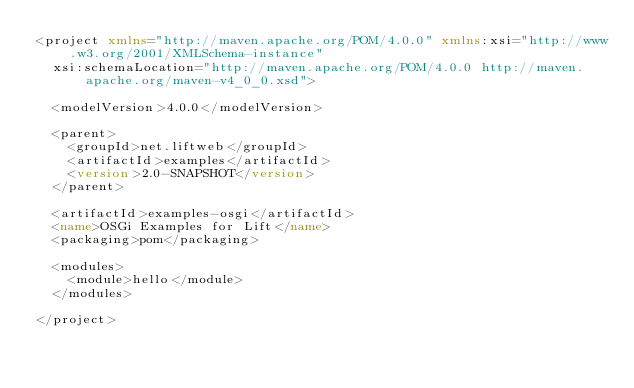Convert code to text. <code><loc_0><loc_0><loc_500><loc_500><_XML_><project xmlns="http://maven.apache.org/POM/4.0.0" xmlns:xsi="http://www.w3.org/2001/XMLSchema-instance"
  xsi:schemaLocation="http://maven.apache.org/POM/4.0.0 http://maven.apache.org/maven-v4_0_0.xsd">

  <modelVersion>4.0.0</modelVersion>

  <parent>
    <groupId>net.liftweb</groupId>
    <artifactId>examples</artifactId>
    <version>2.0-SNAPSHOT</version>
  </parent>

  <artifactId>examples-osgi</artifactId>
  <name>OSGi Examples for Lift</name>
  <packaging>pom</packaging>

  <modules>
    <module>hello</module>
  </modules>

</project>
</code> 